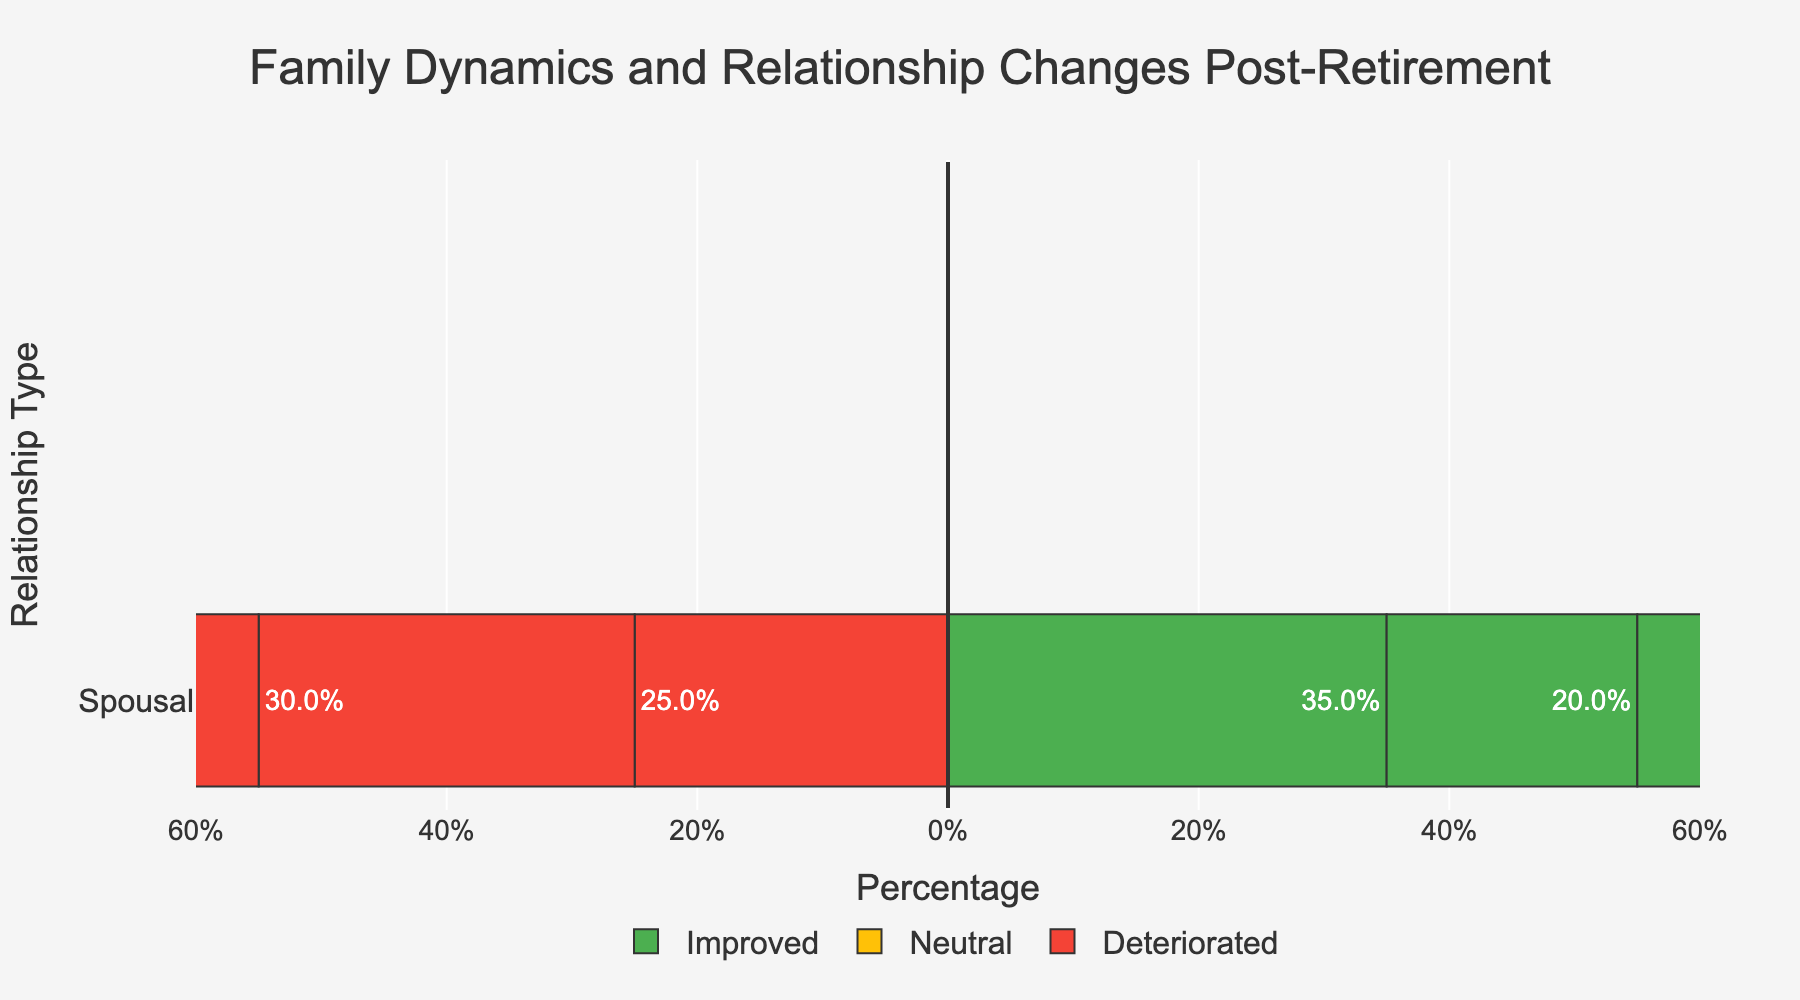Which relationship type experienced the highest percentage of improvement post-retirement? To identify the relationship type with the highest percentage of improvement, look at the "Improved" category bar for each relationship type. The Spousal bar is the tallest, indicating 35%.
Answer: Spousal Which relationship type had the most neutral changes post-retirement? Compare the "Neutral" category bars for all relationship types. The Sibling bar is the tallest at 62.5%.
Answer: Sibling How much higher is the percentage of neutral changes compared to deteriorated changes among parental relationships? The percentage of neutral changes in parental relationships is 50%, and the percentage of deteriorated changes is 30%. The difference is 50% - 30% = 20%.
Answer: 20% What is the total percentage of positive changes across all relationship types? Sum the percentages of "Improved" for Spousal (35%), Parental (20%), and Sibling (17.5%). The total is 35% + 20% + 17.5% = 72.5%.
Answer: 72.5% Which category of changes (Improved, Neutral, or Deteriorated) is the least common in the parental relationship type? Compare the heights of bars in the parental relationship type. "Improved" (20%) is the shortest.
Answer: Improved By what percentage do the neutral changes in spousal relationships exceed the deteriorated changes? Neutral changes in spousal relationships are 40%, and deteriorated changes are 25%. The difference is 40% - 25% = 15%.
Answer: 15% Which relationship type experienced the smallest percentage of improvement? By comparing the "Improved" category bars, the Sibling relationship type has the smallest percentage at 17.5%.
Answer: Sibling Do neutral changes dominate any relationship type post-retirement, and if so, which one? Look for the relationship type where the "Neutral" category has the highest percentage. The Sibling relationship type has the highest neutral percentage at 62.5%.
Answer: Sibling What is the total percentage of neutral and deteriorated changes for sibling relationships? Sum the percentages of "Neutral" (62.5%) and "Deteriorated" (20%) for sibling relationships. The total is 62.5% + 20% = 82.5%.
Answer: 82.5% 